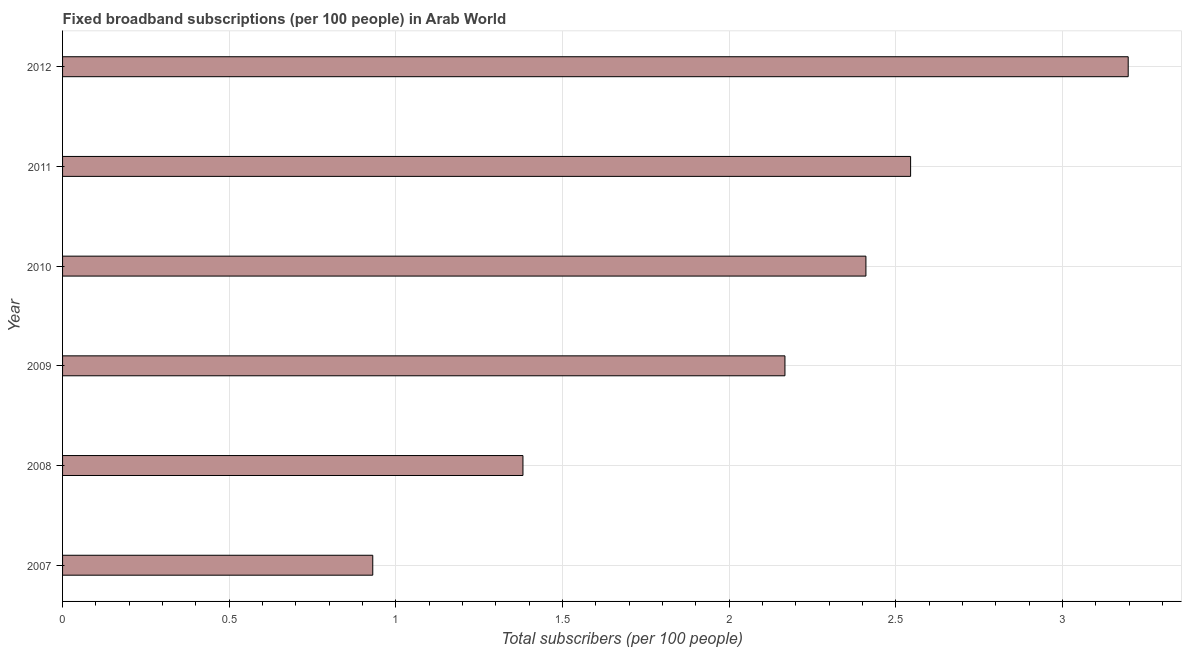Does the graph contain any zero values?
Offer a terse response. No. Does the graph contain grids?
Offer a terse response. Yes. What is the title of the graph?
Make the answer very short. Fixed broadband subscriptions (per 100 people) in Arab World. What is the label or title of the X-axis?
Your response must be concise. Total subscribers (per 100 people). What is the total number of fixed broadband subscriptions in 2012?
Offer a terse response. 3.2. Across all years, what is the maximum total number of fixed broadband subscriptions?
Provide a short and direct response. 3.2. Across all years, what is the minimum total number of fixed broadband subscriptions?
Make the answer very short. 0.93. What is the sum of the total number of fixed broadband subscriptions?
Offer a very short reply. 12.63. What is the difference between the total number of fixed broadband subscriptions in 2010 and 2011?
Provide a short and direct response. -0.13. What is the average total number of fixed broadband subscriptions per year?
Provide a short and direct response. 2.1. What is the median total number of fixed broadband subscriptions?
Provide a succinct answer. 2.29. In how many years, is the total number of fixed broadband subscriptions greater than 1.7 ?
Offer a very short reply. 4. Do a majority of the years between 2011 and 2012 (inclusive) have total number of fixed broadband subscriptions greater than 2.2 ?
Your answer should be compact. Yes. What is the ratio of the total number of fixed broadband subscriptions in 2007 to that in 2009?
Your answer should be very brief. 0.43. Is the total number of fixed broadband subscriptions in 2008 less than that in 2010?
Make the answer very short. Yes. Is the difference between the total number of fixed broadband subscriptions in 2008 and 2010 greater than the difference between any two years?
Your answer should be very brief. No. What is the difference between the highest and the second highest total number of fixed broadband subscriptions?
Ensure brevity in your answer.  0.65. Is the sum of the total number of fixed broadband subscriptions in 2009 and 2010 greater than the maximum total number of fixed broadband subscriptions across all years?
Offer a terse response. Yes. What is the difference between the highest and the lowest total number of fixed broadband subscriptions?
Provide a succinct answer. 2.27. In how many years, is the total number of fixed broadband subscriptions greater than the average total number of fixed broadband subscriptions taken over all years?
Your answer should be compact. 4. How many bars are there?
Make the answer very short. 6. Are the values on the major ticks of X-axis written in scientific E-notation?
Ensure brevity in your answer.  No. What is the Total subscribers (per 100 people) in 2007?
Ensure brevity in your answer.  0.93. What is the Total subscribers (per 100 people) of 2008?
Provide a short and direct response. 1.38. What is the Total subscribers (per 100 people) of 2009?
Provide a succinct answer. 2.17. What is the Total subscribers (per 100 people) in 2010?
Ensure brevity in your answer.  2.41. What is the Total subscribers (per 100 people) of 2011?
Provide a short and direct response. 2.54. What is the Total subscribers (per 100 people) of 2012?
Provide a succinct answer. 3.2. What is the difference between the Total subscribers (per 100 people) in 2007 and 2008?
Your answer should be compact. -0.45. What is the difference between the Total subscribers (per 100 people) in 2007 and 2009?
Make the answer very short. -1.24. What is the difference between the Total subscribers (per 100 people) in 2007 and 2010?
Offer a very short reply. -1.48. What is the difference between the Total subscribers (per 100 people) in 2007 and 2011?
Give a very brief answer. -1.61. What is the difference between the Total subscribers (per 100 people) in 2007 and 2012?
Your answer should be very brief. -2.27. What is the difference between the Total subscribers (per 100 people) in 2008 and 2009?
Offer a terse response. -0.79. What is the difference between the Total subscribers (per 100 people) in 2008 and 2010?
Provide a short and direct response. -1.03. What is the difference between the Total subscribers (per 100 people) in 2008 and 2011?
Your answer should be compact. -1.16. What is the difference between the Total subscribers (per 100 people) in 2008 and 2012?
Your response must be concise. -1.82. What is the difference between the Total subscribers (per 100 people) in 2009 and 2010?
Offer a very short reply. -0.24. What is the difference between the Total subscribers (per 100 people) in 2009 and 2011?
Offer a terse response. -0.38. What is the difference between the Total subscribers (per 100 people) in 2009 and 2012?
Make the answer very short. -1.03. What is the difference between the Total subscribers (per 100 people) in 2010 and 2011?
Your response must be concise. -0.13. What is the difference between the Total subscribers (per 100 people) in 2010 and 2012?
Make the answer very short. -0.79. What is the difference between the Total subscribers (per 100 people) in 2011 and 2012?
Provide a succinct answer. -0.65. What is the ratio of the Total subscribers (per 100 people) in 2007 to that in 2008?
Offer a terse response. 0.67. What is the ratio of the Total subscribers (per 100 people) in 2007 to that in 2009?
Make the answer very short. 0.43. What is the ratio of the Total subscribers (per 100 people) in 2007 to that in 2010?
Give a very brief answer. 0.39. What is the ratio of the Total subscribers (per 100 people) in 2007 to that in 2011?
Provide a short and direct response. 0.37. What is the ratio of the Total subscribers (per 100 people) in 2007 to that in 2012?
Make the answer very short. 0.29. What is the ratio of the Total subscribers (per 100 people) in 2008 to that in 2009?
Provide a succinct answer. 0.64. What is the ratio of the Total subscribers (per 100 people) in 2008 to that in 2010?
Provide a succinct answer. 0.57. What is the ratio of the Total subscribers (per 100 people) in 2008 to that in 2011?
Keep it short and to the point. 0.54. What is the ratio of the Total subscribers (per 100 people) in 2008 to that in 2012?
Ensure brevity in your answer.  0.43. What is the ratio of the Total subscribers (per 100 people) in 2009 to that in 2010?
Make the answer very short. 0.9. What is the ratio of the Total subscribers (per 100 people) in 2009 to that in 2011?
Provide a succinct answer. 0.85. What is the ratio of the Total subscribers (per 100 people) in 2009 to that in 2012?
Provide a succinct answer. 0.68. What is the ratio of the Total subscribers (per 100 people) in 2010 to that in 2011?
Give a very brief answer. 0.95. What is the ratio of the Total subscribers (per 100 people) in 2010 to that in 2012?
Make the answer very short. 0.75. What is the ratio of the Total subscribers (per 100 people) in 2011 to that in 2012?
Ensure brevity in your answer.  0.8. 